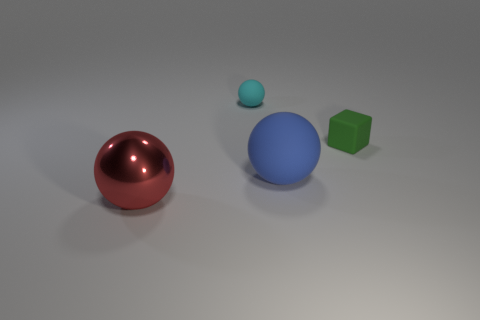Are there any tiny cubes that are in front of the large sphere that is behind the big metal object?
Provide a succinct answer. No. Do the ball behind the green object and the large blue object have the same material?
Offer a very short reply. Yes. Is the large shiny sphere the same color as the rubber block?
Keep it short and to the point. No. How big is the rubber thing that is to the left of the sphere that is to the right of the cyan rubber sphere?
Offer a terse response. Small. Do the large sphere behind the big shiny object and the red thing in front of the tiny green thing have the same material?
Keep it short and to the point. No. There is a tiny thing behind the tiny rubber cube; does it have the same color as the small rubber cube?
Your answer should be very brief. No. What number of cyan things are in front of the rubber cube?
Provide a succinct answer. 0. Do the cube and the big thing that is in front of the large blue sphere have the same material?
Provide a succinct answer. No. What is the size of the green block that is the same material as the small cyan sphere?
Your answer should be very brief. Small. Is the number of cyan rubber things to the left of the metal sphere greater than the number of cyan rubber objects right of the tiny green matte cube?
Your response must be concise. No. 